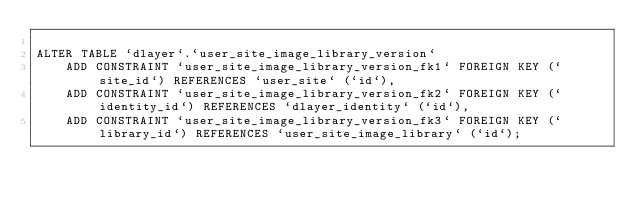<code> <loc_0><loc_0><loc_500><loc_500><_SQL_>
ALTER TABLE `dlayer`.`user_site_image_library_version`
    ADD CONSTRAINT `user_site_image_library_version_fk1` FOREIGN KEY (`site_id`) REFERENCES `user_site` (`id`),
    ADD CONSTRAINT `user_site_image_library_version_fk2` FOREIGN KEY (`identity_id`) REFERENCES `dlayer_identity` (`id`),
    ADD CONSTRAINT `user_site_image_library_version_fk3` FOREIGN KEY (`library_id`) REFERENCES `user_site_image_library` (`id`);
</code> 